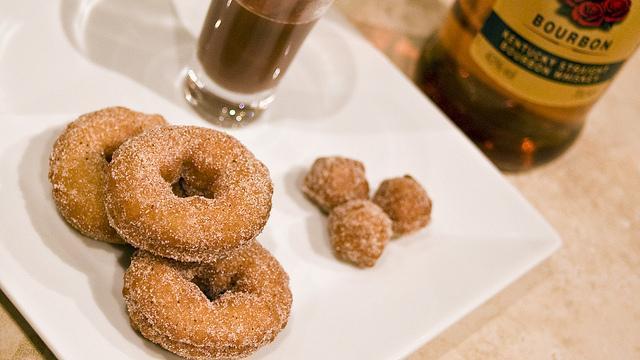How many donuts are pictured here?
Give a very brief answer. 3. How many donuts are in the picture?
Give a very brief answer. 3. How many sets of giraffes have their necks crossed?
Give a very brief answer. 0. 